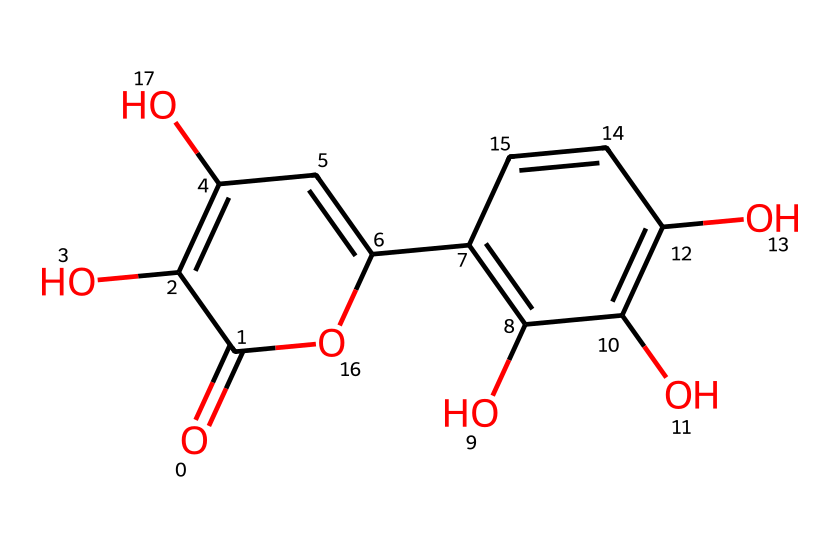how many hydroxyl groups are present in quercetin? By examining the SMILES representation, we can identify the -OH groups (hydroxyl groups) attached to the aromatic rings. There are three distinct -OH groups present in the structure.
Answer: three what is the molecular weight of quercetin? Based on the molecular formula derived from the SMILES structure (C15H10O7), the calculation is done by multiplying the number of each atom by its atomic mass (C: 12.01 g/mol, H: 1.008 g/mol, O: 16.00 g/mol), resulting in an approximate molecular weight of 302.24 g/mol.
Answer: 302.24 which chemical property is mainly responsible for quercetin's antioxidant capability? The presence of multiple hydroxyl (-OH) groups in the structure allows for hydrogen donation, which is crucial for scavenging free radicals, thereby conferring antioxidant properties.
Answer: hydroxyl groups how many rings are in the quercetin structure? The SMILES representation shows that quercetin contains three interconnected rings: one central aromatic ring and two additional aromatic units attached to it, giving a total of three rings.
Answer: three what type of chemical structure does quercetin belong to? Quercetin is categorized as a flavonoid, which is a type of polyphenolic compound characterized by a specific arrangement of carbon rings and hydroxyl groups; this is evident from its structure containing two benzene rings and a ketone.
Answer: flavonoid is quercetin more soluble in water or fat based on its structure? Given the presence of multiple polar hydroxyl groups as evident from its arrangement, quercetin is more soluble in water (hydrophilic nature) compared to lipophilic compounds.
Answer: water which functional group contributes to quercetin's acidic properties? The ketone group (C=O) present in the structure contributes to the weak acidity of quercetin, as it can participate in chemical reactions by donating a proton in certain conditions, which is observed in similar compounds.
Answer: ketone 